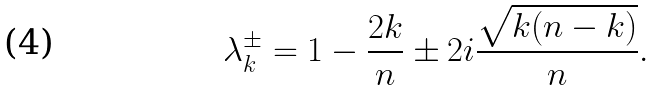<formula> <loc_0><loc_0><loc_500><loc_500>\lambda _ { k } ^ { \pm } = 1 - \frac { 2 k } { n } \pm 2 i \frac { \sqrt { k ( n - k ) } } { n } .</formula> 